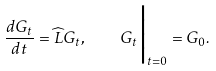<formula> <loc_0><loc_0><loc_500><loc_500>\frac { d G _ { t } } { d t } = \widehat { L } G _ { t } , \quad G _ { t } \Big | _ { t = 0 } = G _ { 0 } .</formula> 